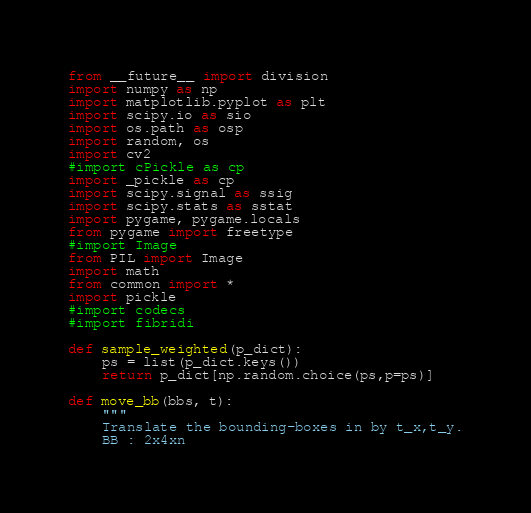Convert code to text. <code><loc_0><loc_0><loc_500><loc_500><_Python_>from __future__ import division
import numpy as np
import matplotlib.pyplot as plt 
import scipy.io as sio
import os.path as osp
import random, os
import cv2
#import cPickle as cp
import _pickle as cp
import scipy.signal as ssig
import scipy.stats as sstat
import pygame, pygame.locals
from pygame import freetype
#import Image
from PIL import Image
import math
from common import *
import pickle
#import codecs
#import fibridi

def sample_weighted(p_dict):
    ps = list(p_dict.keys())
    return p_dict[np.random.choice(ps,p=ps)]

def move_bb(bbs, t):
    """
    Translate the bounding-boxes in by t_x,t_y.
    BB : 2x4xn</code> 